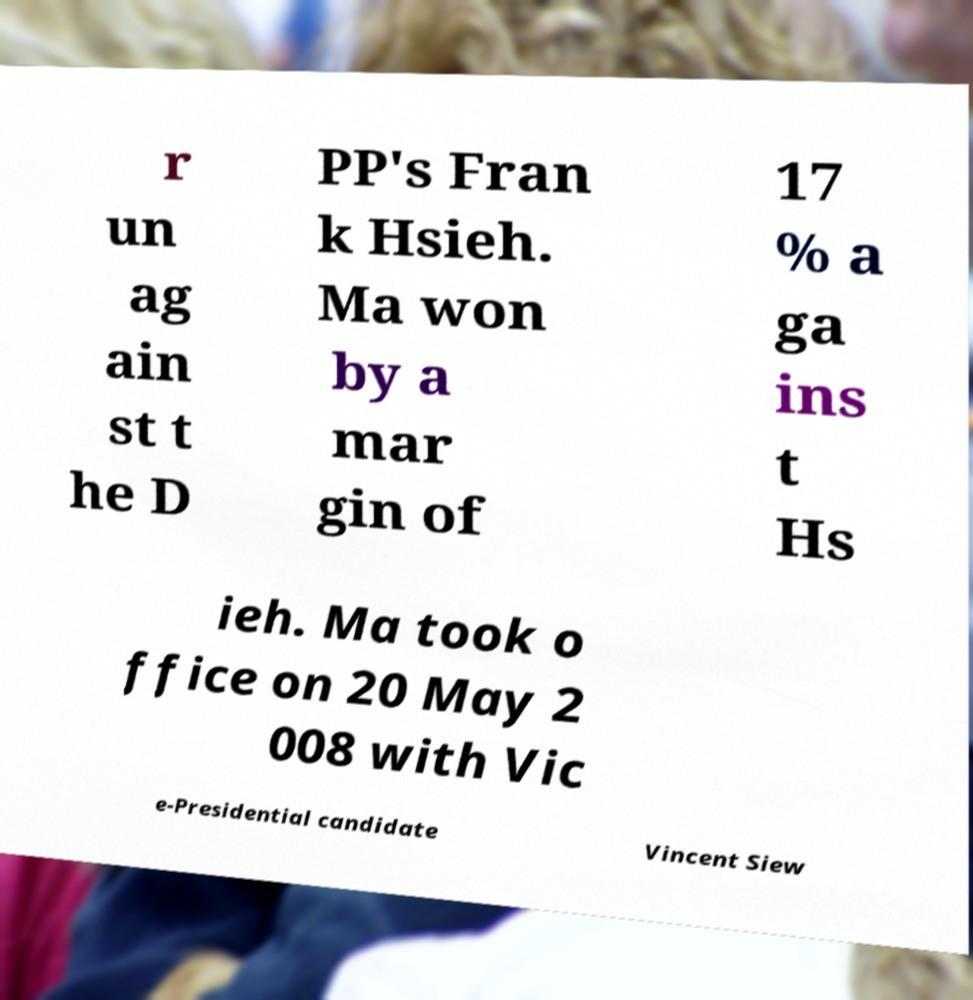For documentation purposes, I need the text within this image transcribed. Could you provide that? r un ag ain st t he D PP's Fran k Hsieh. Ma won by a mar gin of 17 % a ga ins t Hs ieh. Ma took o ffice on 20 May 2 008 with Vic e-Presidential candidate Vincent Siew 